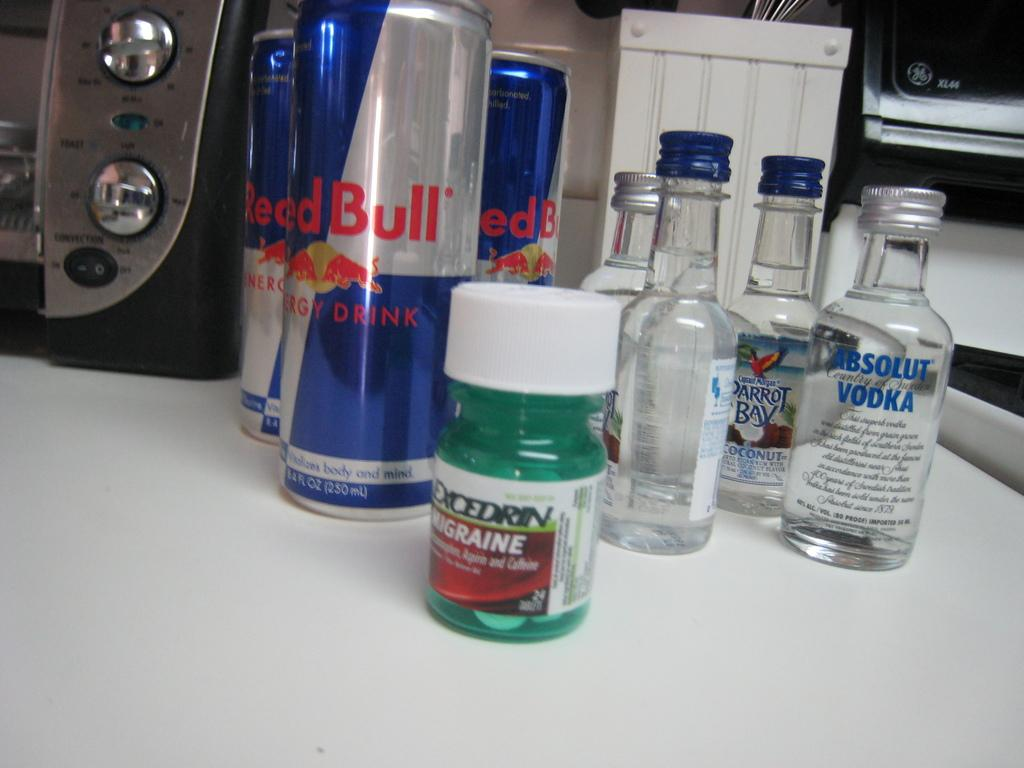What types of bottles are on the table in the image? There are vodka bottles, energy drink bottles, and a migraine bottle on the table. Where are the bottles located in the image? All the bottles are on a table. Where is the nest of oranges located in the image? There is no nest of oranges present in the image. What attraction can be seen in the background of the image? There is no background or attraction visible in the image; it only shows bottles on a table. 